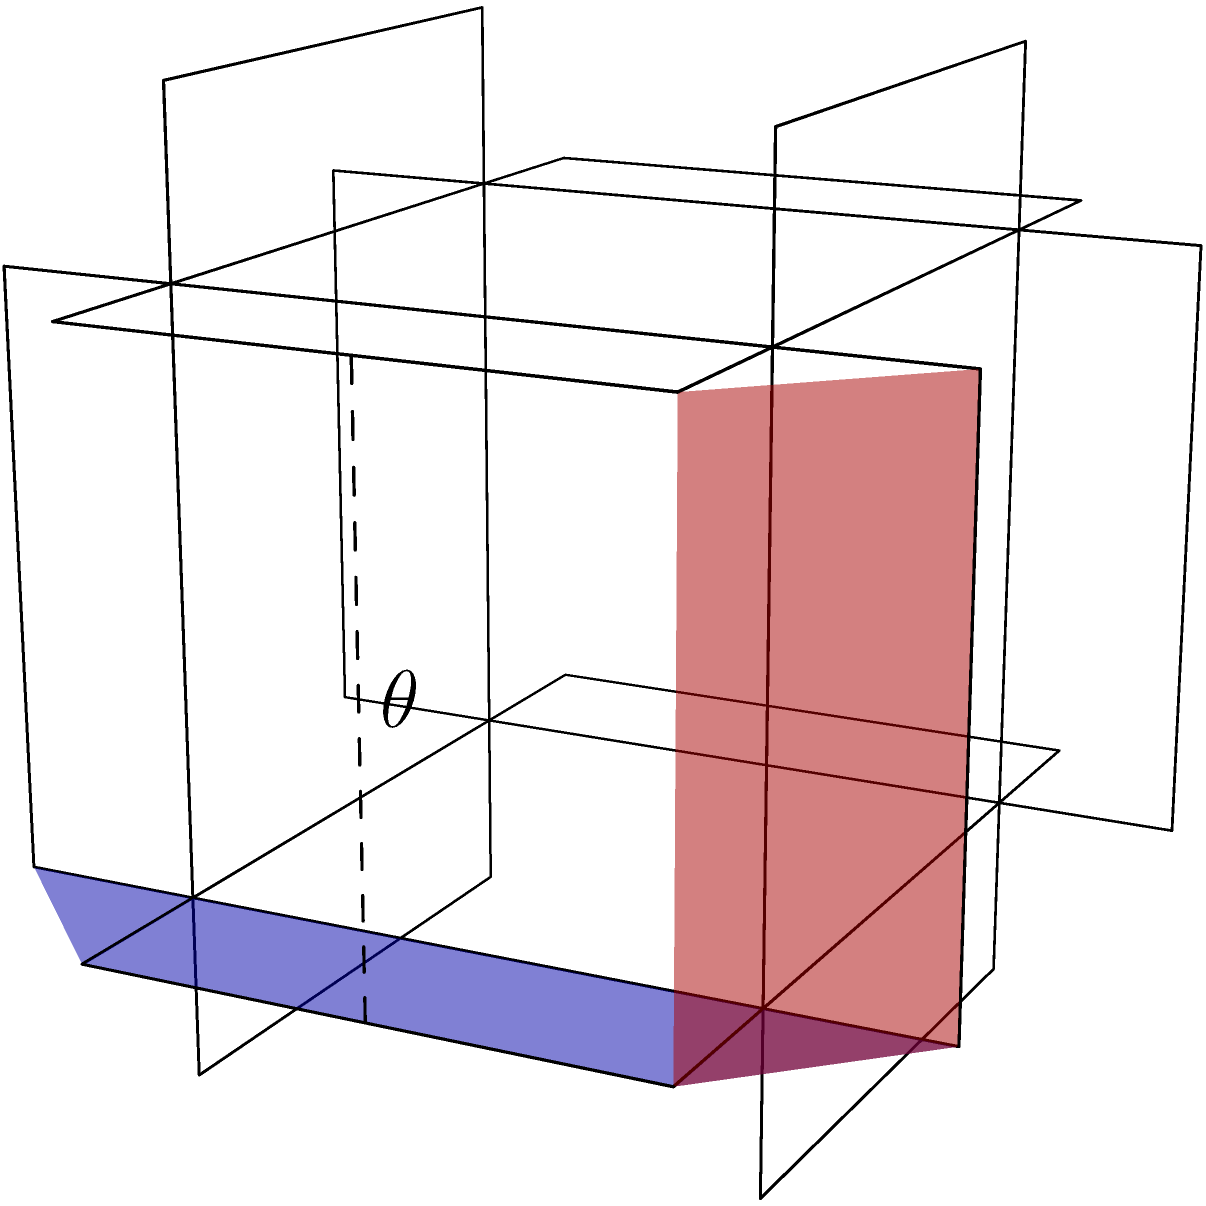In the world of polyhedra, the rhombicosidodecahedron is like the unsung jazz artist of solids. Consider two adjacent faces of this Archimedean solid, as shown in blue and red. What is the angle $\theta$ between these faces? Let's break this down step-by-step, like dissecting a complex jazz composition:

1) The rhombicosidodecahedron has three types of faces: squares, triangles, and pentagons. The highlighted faces are both squares.

2) To find the angle between these faces, we need to calculate the angle between their normal vectors.

3) The normal vectors of these faces can be found by taking the cross product of two edges of each face.

4) For the blue face, let's use vectors $\vec{v_1} = (a+c, a+b, 0)$ and $\vec{v_2} = (-b, a, c)$.
   For the red face, we'll use $\vec{v_3} = (a+c, a+b, 0)$ and $\vec{v_4} = (0, -c, a+b)$.

5) The normal vectors are:
   $\vec{n_1} = \vec{v_1} \times \vec{v_2} = (ac-ab, -ac-bc, a^2+ab+b^2)$
   $\vec{n_2} = \vec{v_3} \times \vec{v_4} = (ac+bc, ac-ab, a^2+ab+b^2)$

6) The angle between these normal vectors is given by:

   $$\cos \theta = \frac{\vec{n_1} \cdot \vec{n_2}}{|\vec{n_1}||\vec{n_2}|}$$

7) Substituting the values and simplifying:

   $$\cos \theta = \frac{a^2c^2-a^2b^2+b^2c^2+(a^2+ab+b^2)^2}{(a^2c^2+a^2b^2+b^2c^2+(a^2+ab+b^2)^2)}$$

8) Recall that for a rhombicosidodecahedron, $b = a/\phi$ and $c = a(\phi-1)$, where $\phi$ is the golden ratio.

9) Substituting these values and simplifying (which involves some complex algebra), we get:

   $$\cos \theta = \frac{3+\sqrt{5}}{5+\sqrt{5}}$$

10) Therefore, $\theta = \arccos(\frac{3+\sqrt{5}}{5+\sqrt{5}}) \approx 26.32°$
Answer: $\arccos(\frac{3+\sqrt{5}}{5+\sqrt{5}})$ or approximately $26.32°$ 